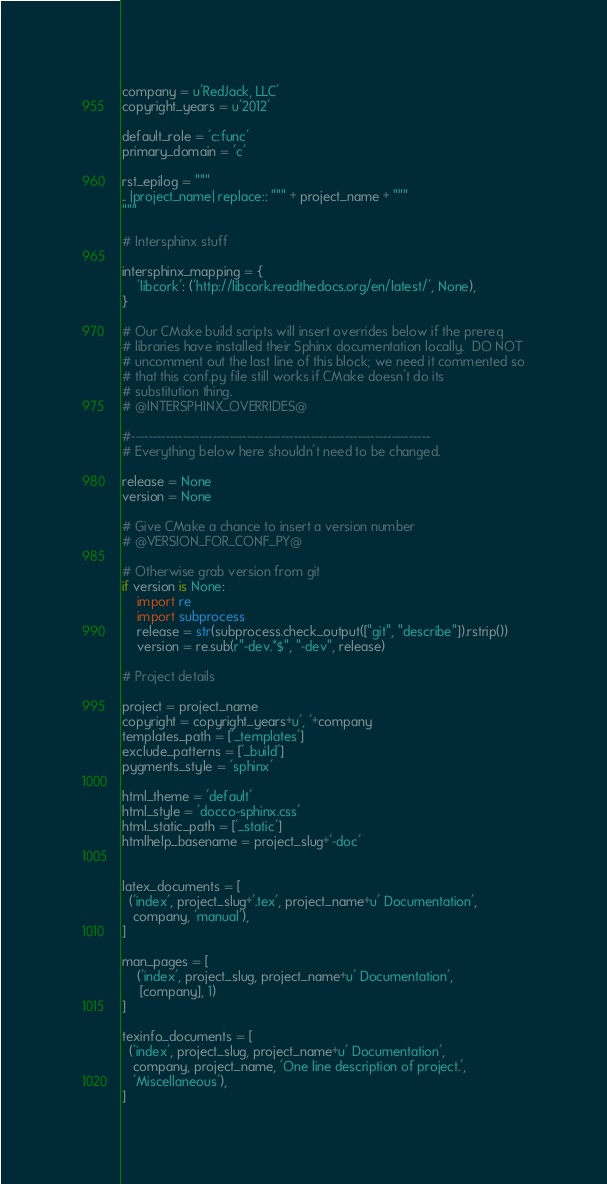<code> <loc_0><loc_0><loc_500><loc_500><_Python_>company = u'RedJack, LLC'
copyright_years = u'2012'

default_role = 'c:func'
primary_domain = 'c'

rst_epilog = """
.. |project_name| replace:: """ + project_name + """
"""

# Intersphinx stuff

intersphinx_mapping = {
    'libcork': ('http://libcork.readthedocs.org/en/latest/', None),
}

# Our CMake build scripts will insert overrides below if the prereq
# libraries have installed their Sphinx documentation locally.  DO NOT
# uncomment out the last line of this block; we need it commented so
# that this conf.py file still works if CMake doesn't do its
# substitution thing.
# @INTERSPHINX_OVERRIDES@

#----------------------------------------------------------------------
# Everything below here shouldn't need to be changed.

release = None
version = None

# Give CMake a chance to insert a version number
# @VERSION_FOR_CONF_PY@

# Otherwise grab version from git
if version is None:
    import re
    import subprocess
    release = str(subprocess.check_output(["git", "describe"]).rstrip())
    version = re.sub(r"-dev.*$", "-dev", release)

# Project details

project = project_name
copyright = copyright_years+u', '+company
templates_path = ['_templates']
exclude_patterns = ['_build']
pygments_style = 'sphinx'

html_theme = 'default'
html_style = 'docco-sphinx.css'
html_static_path = ['_static']
htmlhelp_basename = project_slug+'-doc'


latex_documents = [
  ('index', project_slug+'.tex', project_name+u' Documentation',
   company, 'manual'),
]

man_pages = [
    ('index', project_slug, project_name+u' Documentation',
     [company], 1)
]

texinfo_documents = [
  ('index', project_slug, project_name+u' Documentation',
   company, project_name, 'One line description of project.',
   'Miscellaneous'),
]
</code> 